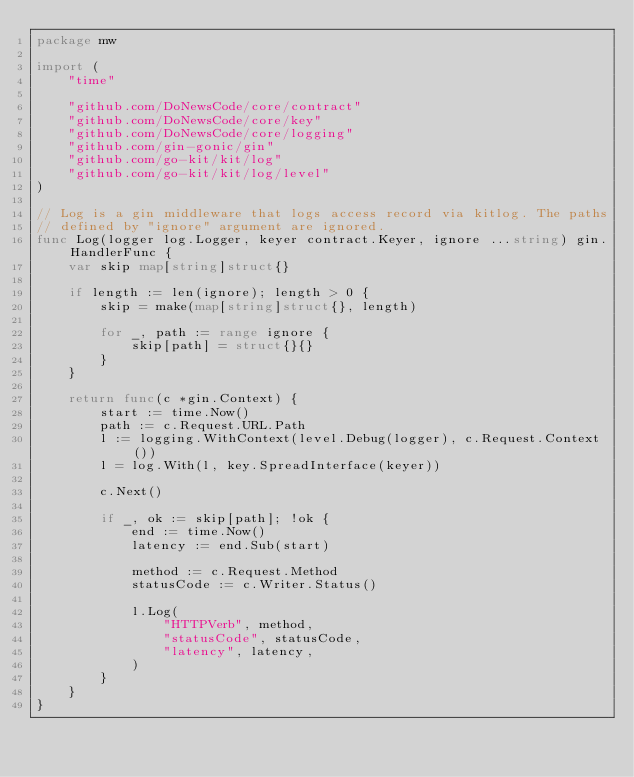Convert code to text. <code><loc_0><loc_0><loc_500><loc_500><_Go_>package mw

import (
	"time"

	"github.com/DoNewsCode/core/contract"
	"github.com/DoNewsCode/core/key"
	"github.com/DoNewsCode/core/logging"
	"github.com/gin-gonic/gin"
	"github.com/go-kit/kit/log"
	"github.com/go-kit/kit/log/level"
)

// Log is a gin middleware that logs access record via kitlog. The paths
// defined by "ignore" argument are ignored.
func Log(logger log.Logger, keyer contract.Keyer, ignore ...string) gin.HandlerFunc {
	var skip map[string]struct{}

	if length := len(ignore); length > 0 {
		skip = make(map[string]struct{}, length)

		for _, path := range ignore {
			skip[path] = struct{}{}
		}
	}

	return func(c *gin.Context) {
		start := time.Now()
		path := c.Request.URL.Path
		l := logging.WithContext(level.Debug(logger), c.Request.Context())
		l = log.With(l, key.SpreadInterface(keyer))

		c.Next()

		if _, ok := skip[path]; !ok {
			end := time.Now()
			latency := end.Sub(start)

			method := c.Request.Method
			statusCode := c.Writer.Status()

			l.Log(
				"HTTPVerb", method,
				"statusCode", statusCode,
				"latency", latency,
			)
		}
	}
}
</code> 